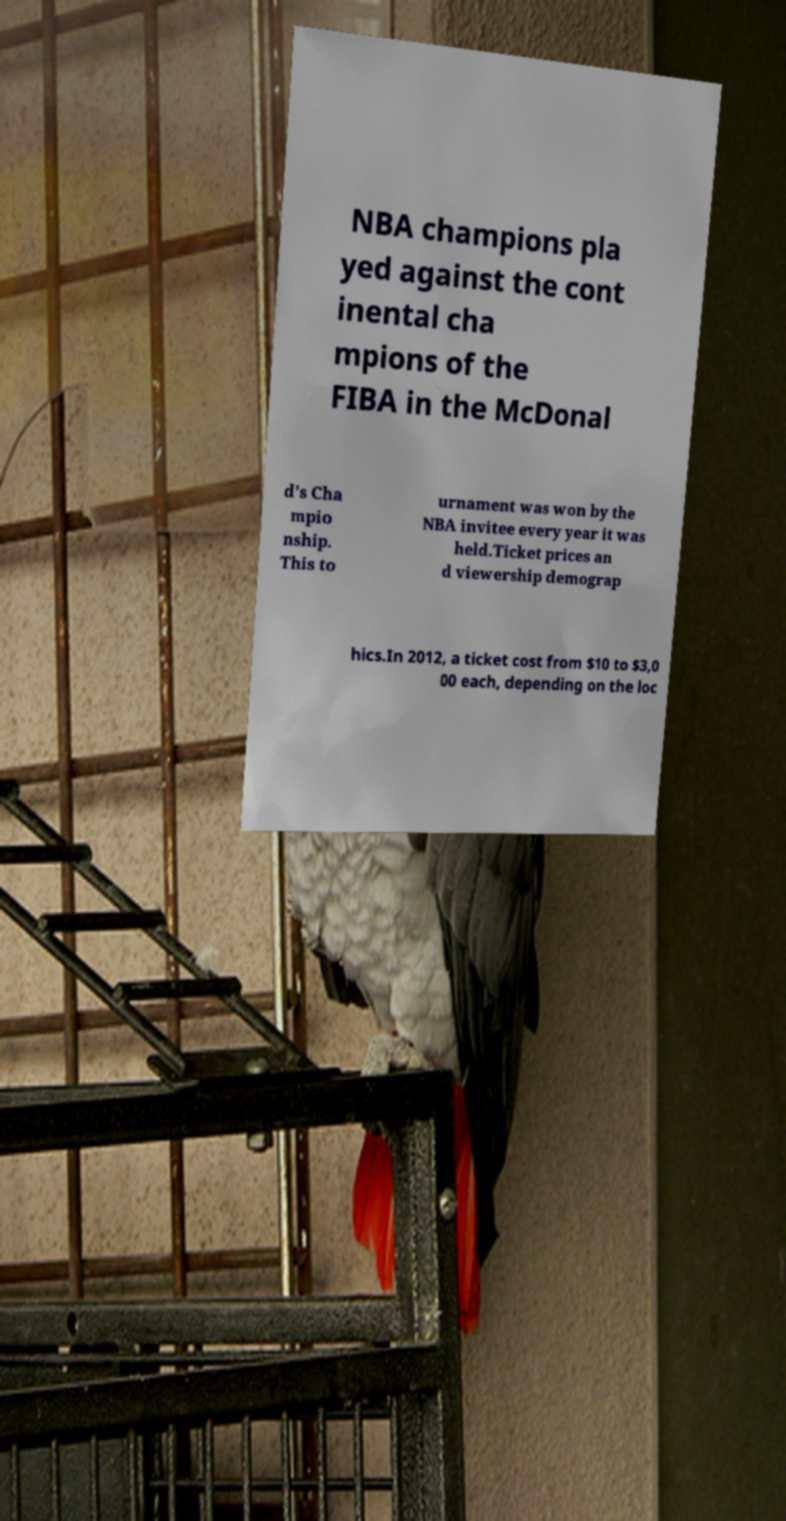Please read and relay the text visible in this image. What does it say? NBA champions pla yed against the cont inental cha mpions of the FIBA in the McDonal d's Cha mpio nship. This to urnament was won by the NBA invitee every year it was held.Ticket prices an d viewership demograp hics.In 2012, a ticket cost from $10 to $3,0 00 each, depending on the loc 